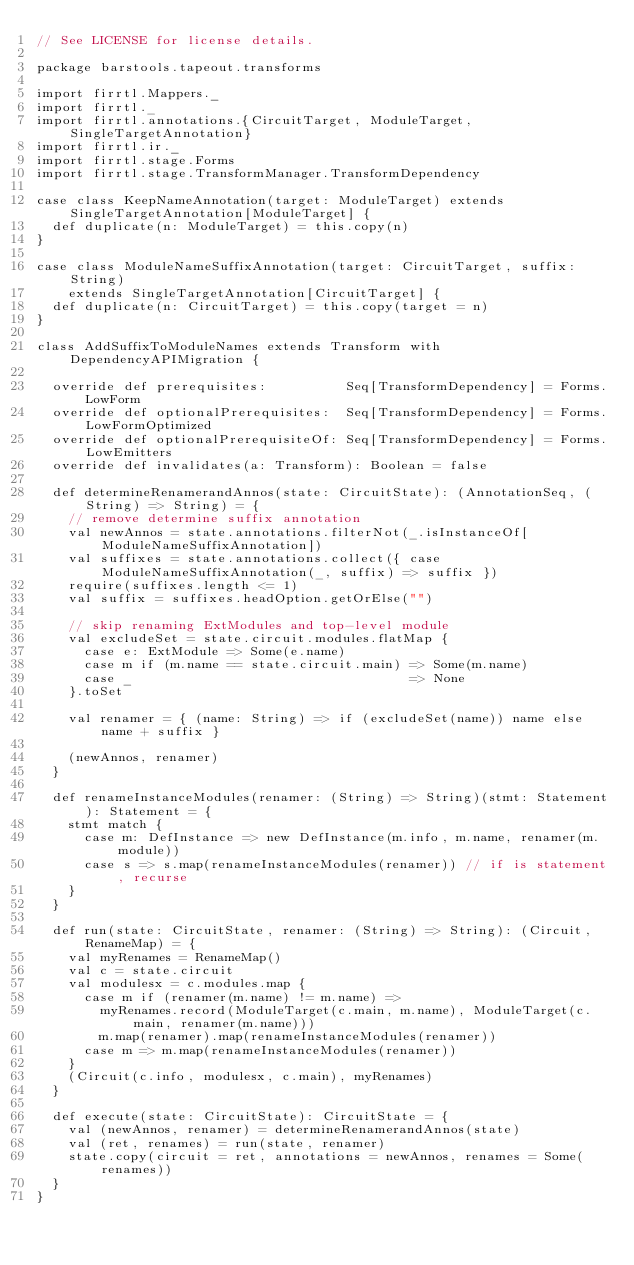<code> <loc_0><loc_0><loc_500><loc_500><_Scala_>// See LICENSE for license details.

package barstools.tapeout.transforms

import firrtl.Mappers._
import firrtl._
import firrtl.annotations.{CircuitTarget, ModuleTarget, SingleTargetAnnotation}
import firrtl.ir._
import firrtl.stage.Forms
import firrtl.stage.TransformManager.TransformDependency

case class KeepNameAnnotation(target: ModuleTarget) extends SingleTargetAnnotation[ModuleTarget] {
  def duplicate(n: ModuleTarget) = this.copy(n)
}

case class ModuleNameSuffixAnnotation(target: CircuitTarget, suffix: String)
    extends SingleTargetAnnotation[CircuitTarget] {
  def duplicate(n: CircuitTarget) = this.copy(target = n)
}

class AddSuffixToModuleNames extends Transform with DependencyAPIMigration {

  override def prerequisites:          Seq[TransformDependency] = Forms.LowForm
  override def optionalPrerequisites:  Seq[TransformDependency] = Forms.LowFormOptimized
  override def optionalPrerequisiteOf: Seq[TransformDependency] = Forms.LowEmitters
  override def invalidates(a: Transform): Boolean = false

  def determineRenamerandAnnos(state: CircuitState): (AnnotationSeq, (String) => String) = {
    // remove determine suffix annotation
    val newAnnos = state.annotations.filterNot(_.isInstanceOf[ModuleNameSuffixAnnotation])
    val suffixes = state.annotations.collect({ case ModuleNameSuffixAnnotation(_, suffix) => suffix })
    require(suffixes.length <= 1)
    val suffix = suffixes.headOption.getOrElse("")

    // skip renaming ExtModules and top-level module
    val excludeSet = state.circuit.modules.flatMap {
      case e: ExtModule => Some(e.name)
      case m if (m.name == state.circuit.main) => Some(m.name)
      case _                                   => None
    }.toSet

    val renamer = { (name: String) => if (excludeSet(name)) name else name + suffix }

    (newAnnos, renamer)
  }

  def renameInstanceModules(renamer: (String) => String)(stmt: Statement): Statement = {
    stmt match {
      case m: DefInstance => new DefInstance(m.info, m.name, renamer(m.module))
      case s => s.map(renameInstanceModules(renamer)) // if is statement, recurse
    }
  }

  def run(state: CircuitState, renamer: (String) => String): (Circuit, RenameMap) = {
    val myRenames = RenameMap()
    val c = state.circuit
    val modulesx = c.modules.map {
      case m if (renamer(m.name) != m.name) =>
        myRenames.record(ModuleTarget(c.main, m.name), ModuleTarget(c.main, renamer(m.name)))
        m.map(renamer).map(renameInstanceModules(renamer))
      case m => m.map(renameInstanceModules(renamer))
    }
    (Circuit(c.info, modulesx, c.main), myRenames)
  }

  def execute(state: CircuitState): CircuitState = {
    val (newAnnos, renamer) = determineRenamerandAnnos(state)
    val (ret, renames) = run(state, renamer)
    state.copy(circuit = ret, annotations = newAnnos, renames = Some(renames))
  }
}
</code> 